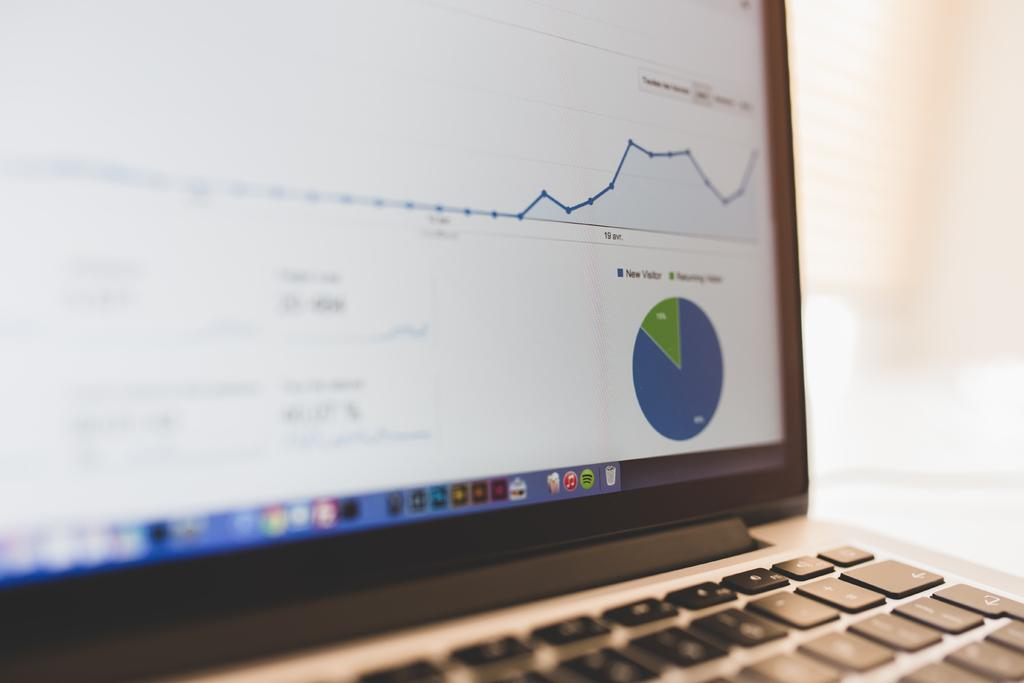<image>
Offer a succinct explanation of the picture presented. Laptop computer screen with a new visitor pie chart in the corner. 